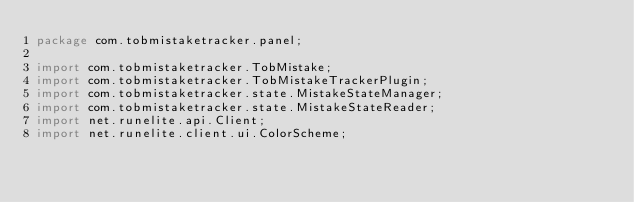Convert code to text. <code><loc_0><loc_0><loc_500><loc_500><_Java_>package com.tobmistaketracker.panel;

import com.tobmistaketracker.TobMistake;
import com.tobmistaketracker.TobMistakeTrackerPlugin;
import com.tobmistaketracker.state.MistakeStateManager;
import com.tobmistaketracker.state.MistakeStateReader;
import net.runelite.api.Client;
import net.runelite.client.ui.ColorScheme;</code> 